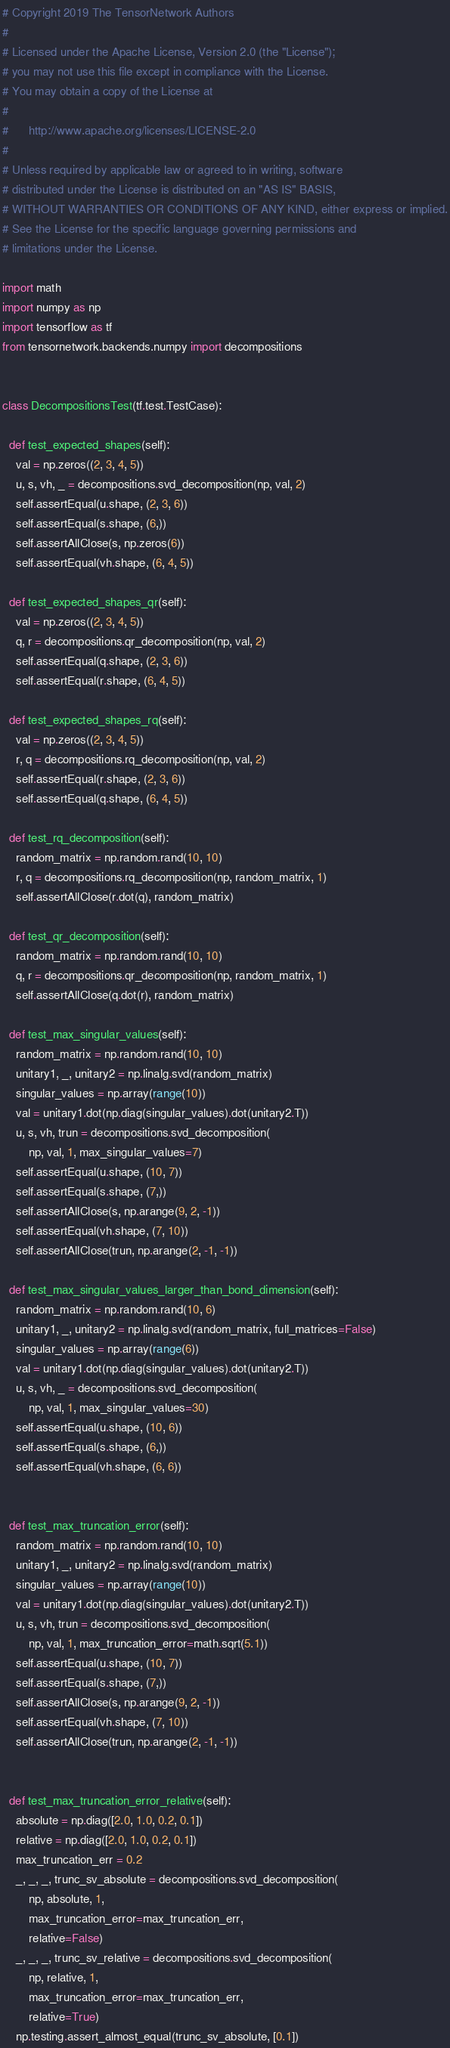<code> <loc_0><loc_0><loc_500><loc_500><_Python_># Copyright 2019 The TensorNetwork Authors
#
# Licensed under the Apache License, Version 2.0 (the "License");
# you may not use this file except in compliance with the License.
# You may obtain a copy of the License at
#
#      http://www.apache.org/licenses/LICENSE-2.0
#
# Unless required by applicable law or agreed to in writing, software
# distributed under the License is distributed on an "AS IS" BASIS,
# WITHOUT WARRANTIES OR CONDITIONS OF ANY KIND, either express or implied.
# See the License for the specific language governing permissions and
# limitations under the License.

import math
import numpy as np
import tensorflow as tf
from tensornetwork.backends.numpy import decompositions


class DecompositionsTest(tf.test.TestCase):

  def test_expected_shapes(self):
    val = np.zeros((2, 3, 4, 5))
    u, s, vh, _ = decompositions.svd_decomposition(np, val, 2)
    self.assertEqual(u.shape, (2, 3, 6))
    self.assertEqual(s.shape, (6,))
    self.assertAllClose(s, np.zeros(6))
    self.assertEqual(vh.shape, (6, 4, 5))

  def test_expected_shapes_qr(self):
    val = np.zeros((2, 3, 4, 5))
    q, r = decompositions.qr_decomposition(np, val, 2)
    self.assertEqual(q.shape, (2, 3, 6))
    self.assertEqual(r.shape, (6, 4, 5))

  def test_expected_shapes_rq(self):
    val = np.zeros((2, 3, 4, 5))
    r, q = decompositions.rq_decomposition(np, val, 2)
    self.assertEqual(r.shape, (2, 3, 6))
    self.assertEqual(q.shape, (6, 4, 5))

  def test_rq_decomposition(self):
    random_matrix = np.random.rand(10, 10)
    r, q = decompositions.rq_decomposition(np, random_matrix, 1)
    self.assertAllClose(r.dot(q), random_matrix)

  def test_qr_decomposition(self):
    random_matrix = np.random.rand(10, 10)
    q, r = decompositions.qr_decomposition(np, random_matrix, 1)
    self.assertAllClose(q.dot(r), random_matrix)

  def test_max_singular_values(self):
    random_matrix = np.random.rand(10, 10)
    unitary1, _, unitary2 = np.linalg.svd(random_matrix)
    singular_values = np.array(range(10))
    val = unitary1.dot(np.diag(singular_values).dot(unitary2.T))
    u, s, vh, trun = decompositions.svd_decomposition(
        np, val, 1, max_singular_values=7)
    self.assertEqual(u.shape, (10, 7))
    self.assertEqual(s.shape, (7,))
    self.assertAllClose(s, np.arange(9, 2, -1))
    self.assertEqual(vh.shape, (7, 10))
    self.assertAllClose(trun, np.arange(2, -1, -1))

  def test_max_singular_values_larger_than_bond_dimension(self):
    random_matrix = np.random.rand(10, 6)
    unitary1, _, unitary2 = np.linalg.svd(random_matrix, full_matrices=False)
    singular_values = np.array(range(6))
    val = unitary1.dot(np.diag(singular_values).dot(unitary2.T))
    u, s, vh, _ = decompositions.svd_decomposition(
        np, val, 1, max_singular_values=30)
    self.assertEqual(u.shape, (10, 6))
    self.assertEqual(s.shape, (6,))
    self.assertEqual(vh.shape, (6, 6))


  def test_max_truncation_error(self):
    random_matrix = np.random.rand(10, 10)
    unitary1, _, unitary2 = np.linalg.svd(random_matrix)
    singular_values = np.array(range(10))
    val = unitary1.dot(np.diag(singular_values).dot(unitary2.T))
    u, s, vh, trun = decompositions.svd_decomposition(
        np, val, 1, max_truncation_error=math.sqrt(5.1))
    self.assertEqual(u.shape, (10, 7))
    self.assertEqual(s.shape, (7,))
    self.assertAllClose(s, np.arange(9, 2, -1))
    self.assertEqual(vh.shape, (7, 10))
    self.assertAllClose(trun, np.arange(2, -1, -1))


  def test_max_truncation_error_relative(self):
    absolute = np.diag([2.0, 1.0, 0.2, 0.1])
    relative = np.diag([2.0, 1.0, 0.2, 0.1])
    max_truncation_err = 0.2
    _, _, _, trunc_sv_absolute = decompositions.svd_decomposition(
        np, absolute, 1,
        max_truncation_error=max_truncation_err,
        relative=False)
    _, _, _, trunc_sv_relative = decompositions.svd_decomposition(
        np, relative, 1,
        max_truncation_error=max_truncation_err,
        relative=True)
    np.testing.assert_almost_equal(trunc_sv_absolute, [0.1])</code> 